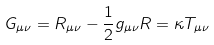Convert formula to latex. <formula><loc_0><loc_0><loc_500><loc_500>G _ { \mu \nu } = R _ { \mu \nu } - \frac { 1 } { 2 } g _ { \mu \nu } R = \kappa T _ { \mu \nu }</formula> 